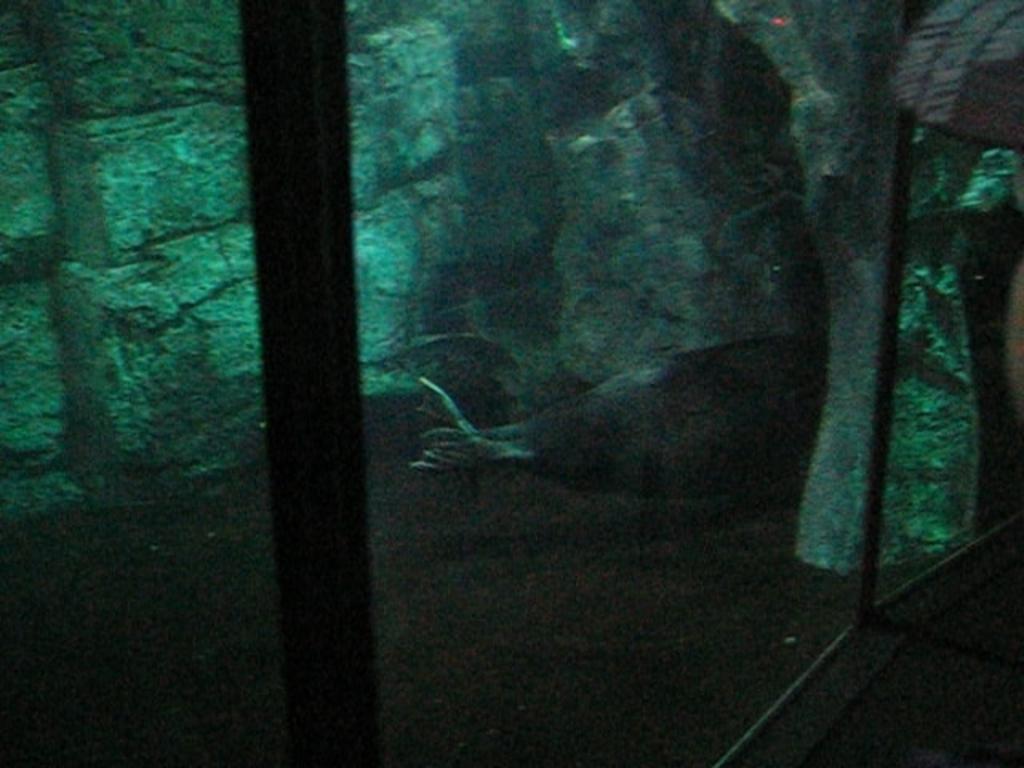In one or two sentences, can you explain what this image depicts? In this image we can see the glass wall and through the glass we can see a fish in the water and stones wall. 